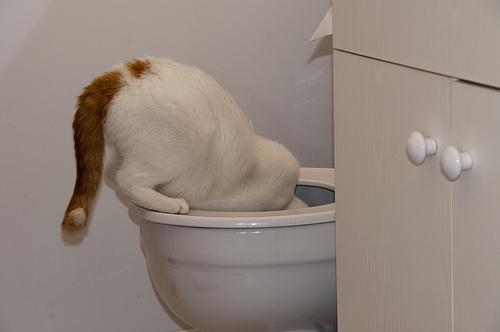Create a simple phrase that highlights the main subject in the picture and their activity. Cat drinking from toilet in white bathroom. Craft a short sentence that summarizes the primary action and noteworthy objects in the scene. In a white bathroom, a cat drinks from a toilet near a wooden cabinet with white knobs. Give a brief description of the main subject and its surroundings in the photo. A cat with its head in the toilet bowl, leaning on the white seat, with bathroom cabinet and white wall in the background. Write a single sentence capturing the main components and scenario of the image. A curious cat with a brown tail and white back is drinking water from a toilet in a brightly lit, white bathroom. Describe the primary object and its physical features, along with what they are doing. A brown and white cat with a brown tail is leaning into a white toilet, drinking water from the toilet bowl. Write a short descriptive sentence focusing on the cat's appearance and its activity. The cat with white paws and a brown tail is sticking its head into the toilet bowl to drink water. Use a different sentence structure to describe the key objects and action in the image. A cat is leaning over a white toilet, with its head inside the bowl, drinking water in a bathroom with white cabinets. List the main objects and actions present in the image. cat, toilet, drinking, bathroom cabinet, white nobs, white wall Mention the key object and associated action in a concise statement. A cat is drinking out of a toilet in a white bathroom. Explain the primary object and activity in the image in a short, precise phrase. Cat quenching its thirst from a white toilet bowl. 